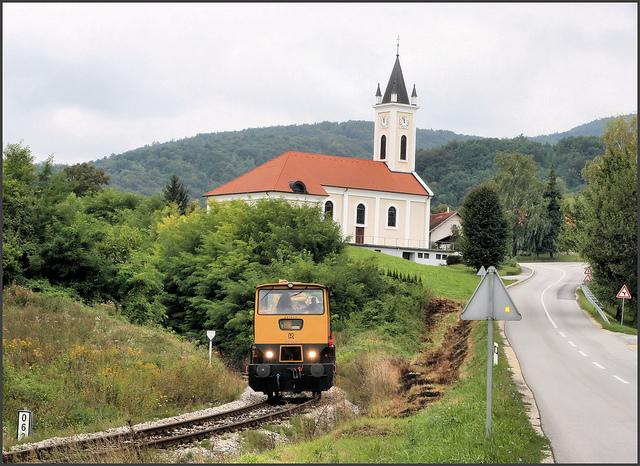What period of the day is shown here?

Choices:
A) afternoon
B) evening
C) early morning
D) almost noon almost noon 